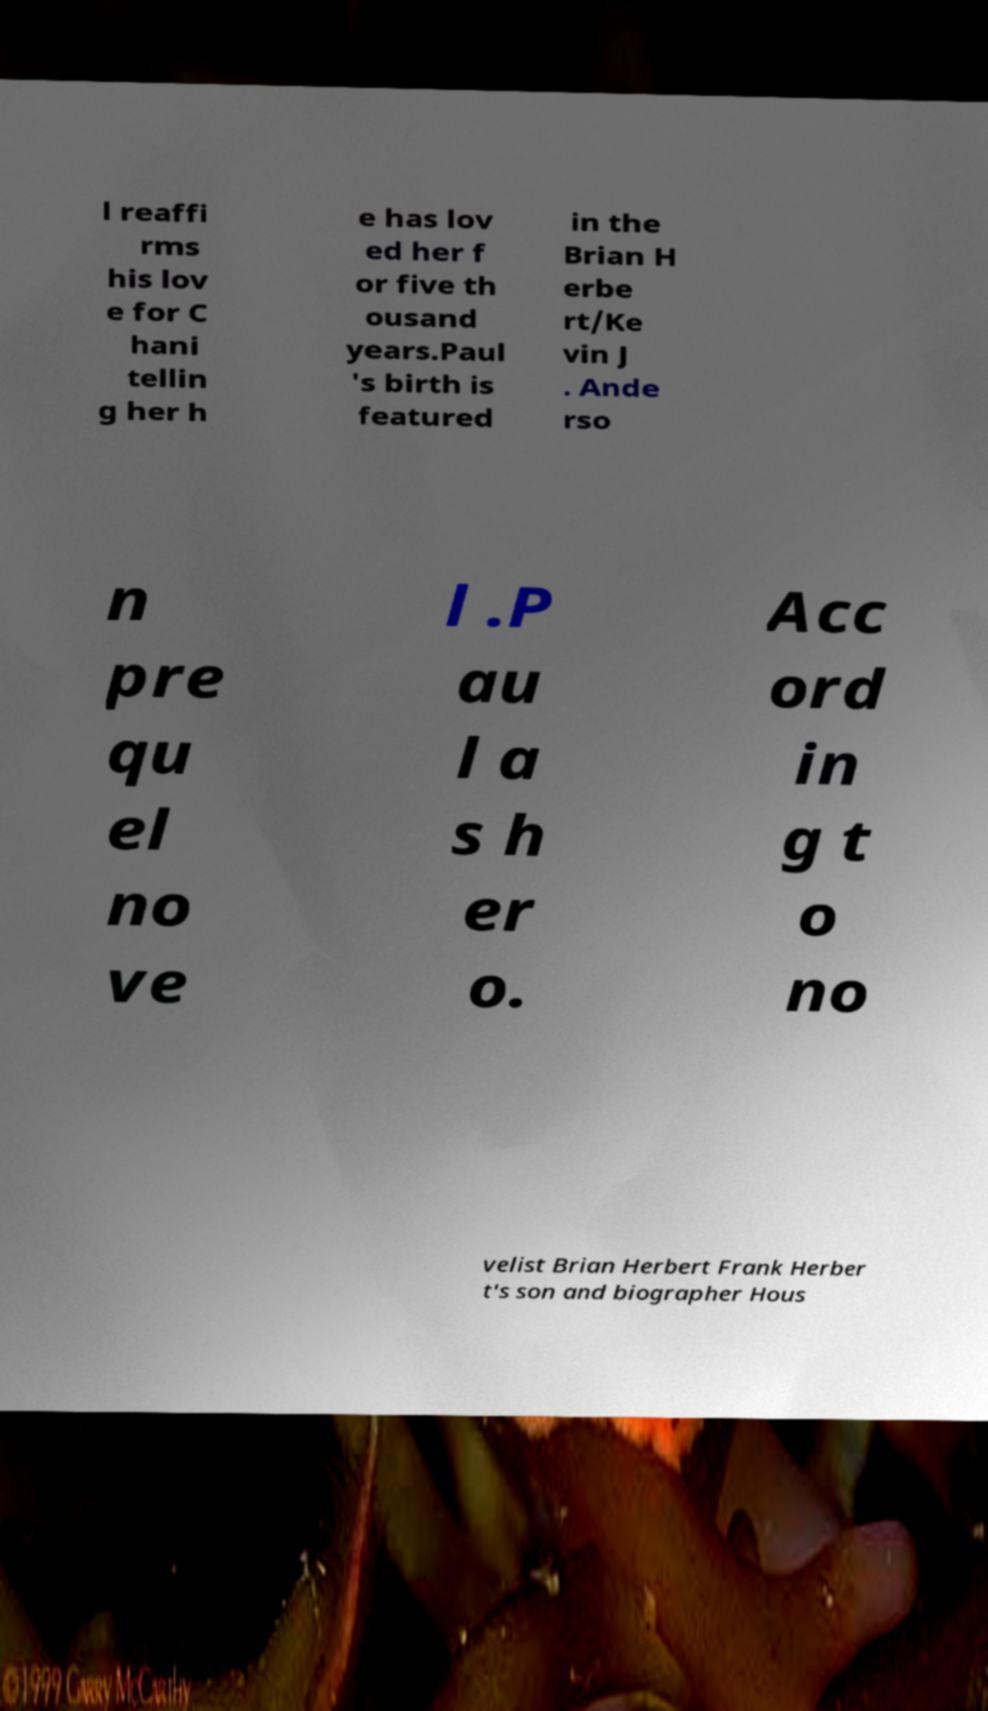Can you read and provide the text displayed in the image?This photo seems to have some interesting text. Can you extract and type it out for me? l reaffi rms his lov e for C hani tellin g her h e has lov ed her f or five th ousand years.Paul 's birth is featured in the Brian H erbe rt/Ke vin J . Ande rso n pre qu el no ve l .P au l a s h er o. Acc ord in g t o no velist Brian Herbert Frank Herber t's son and biographer Hous 